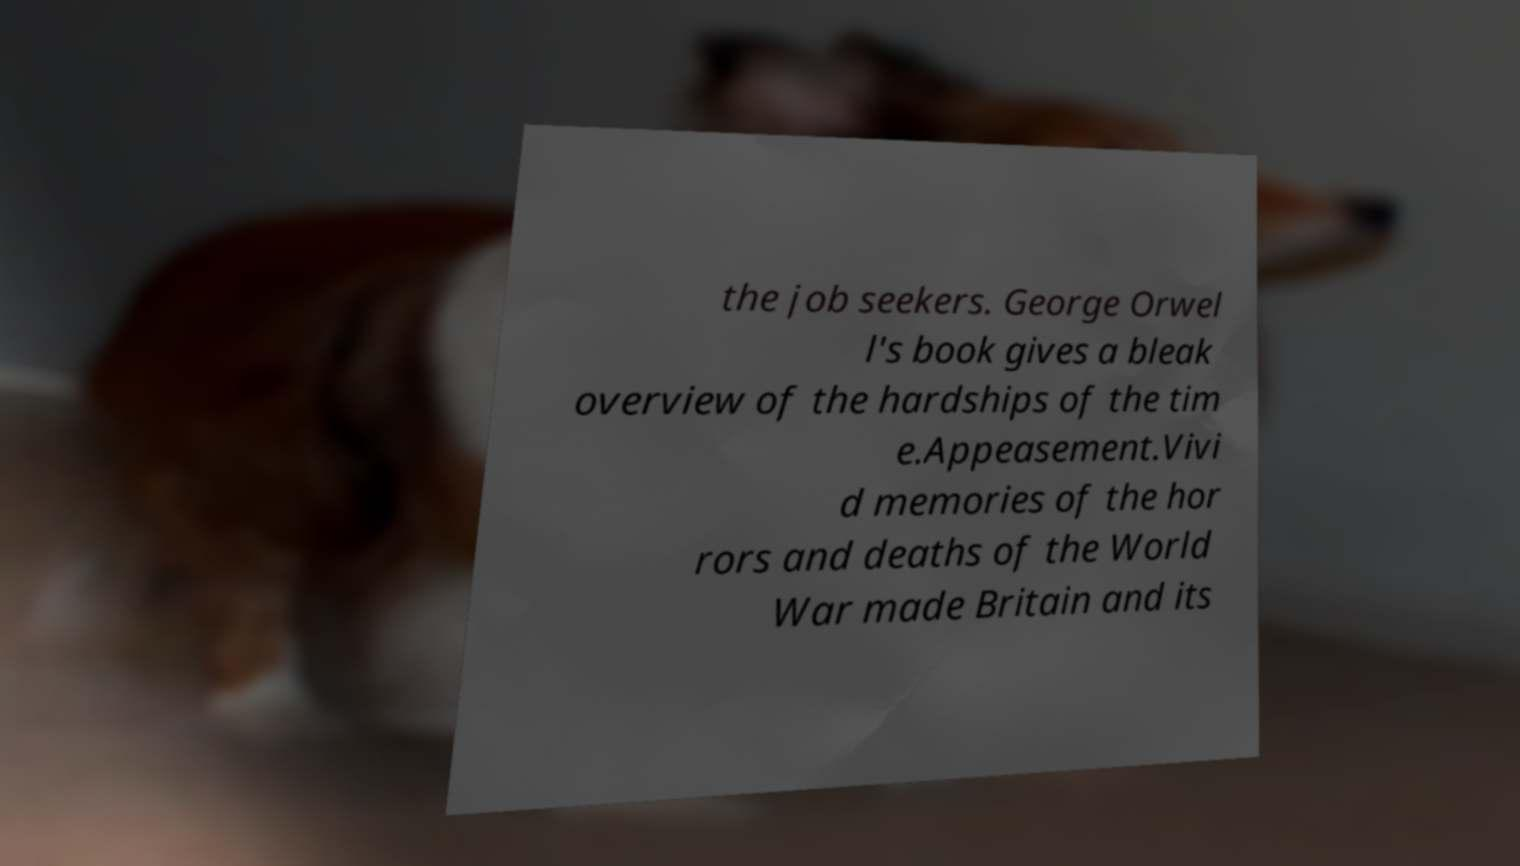Could you extract and type out the text from this image? the job seekers. George Orwel l's book gives a bleak overview of the hardships of the tim e.Appeasement.Vivi d memories of the hor rors and deaths of the World War made Britain and its 